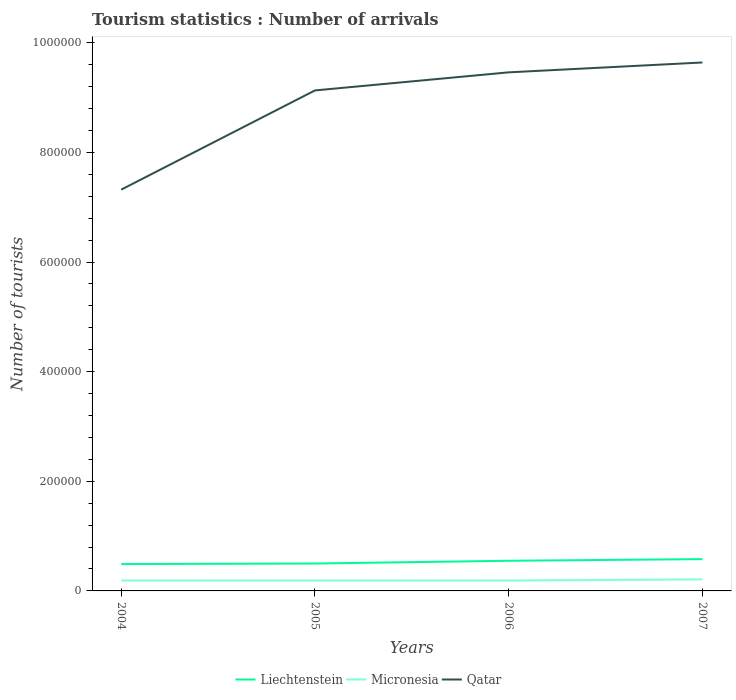Does the line corresponding to Liechtenstein intersect with the line corresponding to Micronesia?
Offer a terse response. No. Is the number of lines equal to the number of legend labels?
Provide a short and direct response. Yes. Across all years, what is the maximum number of tourist arrivals in Micronesia?
Make the answer very short. 1.90e+04. What is the total number of tourist arrivals in Micronesia in the graph?
Provide a succinct answer. 0. Are the values on the major ticks of Y-axis written in scientific E-notation?
Your answer should be very brief. No. Does the graph contain any zero values?
Your answer should be very brief. No. Where does the legend appear in the graph?
Make the answer very short. Bottom center. How are the legend labels stacked?
Offer a very short reply. Horizontal. What is the title of the graph?
Ensure brevity in your answer.  Tourism statistics : Number of arrivals. Does "Slovak Republic" appear as one of the legend labels in the graph?
Your answer should be compact. No. What is the label or title of the X-axis?
Offer a very short reply. Years. What is the label or title of the Y-axis?
Offer a terse response. Number of tourists. What is the Number of tourists in Liechtenstein in 2004?
Offer a terse response. 4.90e+04. What is the Number of tourists in Micronesia in 2004?
Your answer should be very brief. 1.90e+04. What is the Number of tourists in Qatar in 2004?
Keep it short and to the point. 7.32e+05. What is the Number of tourists of Micronesia in 2005?
Ensure brevity in your answer.  1.90e+04. What is the Number of tourists in Qatar in 2005?
Offer a terse response. 9.13e+05. What is the Number of tourists in Liechtenstein in 2006?
Make the answer very short. 5.50e+04. What is the Number of tourists in Micronesia in 2006?
Your response must be concise. 1.90e+04. What is the Number of tourists in Qatar in 2006?
Offer a terse response. 9.46e+05. What is the Number of tourists of Liechtenstein in 2007?
Your answer should be very brief. 5.80e+04. What is the Number of tourists in Micronesia in 2007?
Give a very brief answer. 2.10e+04. What is the Number of tourists of Qatar in 2007?
Ensure brevity in your answer.  9.64e+05. Across all years, what is the maximum Number of tourists in Liechtenstein?
Your answer should be very brief. 5.80e+04. Across all years, what is the maximum Number of tourists in Micronesia?
Make the answer very short. 2.10e+04. Across all years, what is the maximum Number of tourists in Qatar?
Give a very brief answer. 9.64e+05. Across all years, what is the minimum Number of tourists of Liechtenstein?
Provide a succinct answer. 4.90e+04. Across all years, what is the minimum Number of tourists of Micronesia?
Keep it short and to the point. 1.90e+04. Across all years, what is the minimum Number of tourists in Qatar?
Provide a succinct answer. 7.32e+05. What is the total Number of tourists of Liechtenstein in the graph?
Give a very brief answer. 2.12e+05. What is the total Number of tourists of Micronesia in the graph?
Your answer should be very brief. 7.80e+04. What is the total Number of tourists in Qatar in the graph?
Offer a very short reply. 3.56e+06. What is the difference between the Number of tourists in Liechtenstein in 2004 and that in 2005?
Provide a succinct answer. -1000. What is the difference between the Number of tourists of Micronesia in 2004 and that in 2005?
Offer a terse response. 0. What is the difference between the Number of tourists in Qatar in 2004 and that in 2005?
Your answer should be compact. -1.81e+05. What is the difference between the Number of tourists in Liechtenstein in 2004 and that in 2006?
Provide a succinct answer. -6000. What is the difference between the Number of tourists of Micronesia in 2004 and that in 2006?
Offer a very short reply. 0. What is the difference between the Number of tourists in Qatar in 2004 and that in 2006?
Provide a succinct answer. -2.14e+05. What is the difference between the Number of tourists of Liechtenstein in 2004 and that in 2007?
Give a very brief answer. -9000. What is the difference between the Number of tourists in Micronesia in 2004 and that in 2007?
Your answer should be very brief. -2000. What is the difference between the Number of tourists of Qatar in 2004 and that in 2007?
Make the answer very short. -2.32e+05. What is the difference between the Number of tourists of Liechtenstein in 2005 and that in 2006?
Your response must be concise. -5000. What is the difference between the Number of tourists in Micronesia in 2005 and that in 2006?
Provide a succinct answer. 0. What is the difference between the Number of tourists of Qatar in 2005 and that in 2006?
Your answer should be compact. -3.30e+04. What is the difference between the Number of tourists of Liechtenstein in 2005 and that in 2007?
Offer a very short reply. -8000. What is the difference between the Number of tourists in Micronesia in 2005 and that in 2007?
Offer a terse response. -2000. What is the difference between the Number of tourists of Qatar in 2005 and that in 2007?
Provide a succinct answer. -5.10e+04. What is the difference between the Number of tourists of Liechtenstein in 2006 and that in 2007?
Your response must be concise. -3000. What is the difference between the Number of tourists in Micronesia in 2006 and that in 2007?
Provide a succinct answer. -2000. What is the difference between the Number of tourists in Qatar in 2006 and that in 2007?
Your response must be concise. -1.80e+04. What is the difference between the Number of tourists of Liechtenstein in 2004 and the Number of tourists of Micronesia in 2005?
Keep it short and to the point. 3.00e+04. What is the difference between the Number of tourists of Liechtenstein in 2004 and the Number of tourists of Qatar in 2005?
Give a very brief answer. -8.64e+05. What is the difference between the Number of tourists in Micronesia in 2004 and the Number of tourists in Qatar in 2005?
Your answer should be compact. -8.94e+05. What is the difference between the Number of tourists of Liechtenstein in 2004 and the Number of tourists of Qatar in 2006?
Your answer should be compact. -8.97e+05. What is the difference between the Number of tourists in Micronesia in 2004 and the Number of tourists in Qatar in 2006?
Provide a short and direct response. -9.27e+05. What is the difference between the Number of tourists of Liechtenstein in 2004 and the Number of tourists of Micronesia in 2007?
Make the answer very short. 2.80e+04. What is the difference between the Number of tourists of Liechtenstein in 2004 and the Number of tourists of Qatar in 2007?
Make the answer very short. -9.15e+05. What is the difference between the Number of tourists of Micronesia in 2004 and the Number of tourists of Qatar in 2007?
Keep it short and to the point. -9.45e+05. What is the difference between the Number of tourists of Liechtenstein in 2005 and the Number of tourists of Micronesia in 2006?
Your answer should be very brief. 3.10e+04. What is the difference between the Number of tourists in Liechtenstein in 2005 and the Number of tourists in Qatar in 2006?
Keep it short and to the point. -8.96e+05. What is the difference between the Number of tourists in Micronesia in 2005 and the Number of tourists in Qatar in 2006?
Provide a succinct answer. -9.27e+05. What is the difference between the Number of tourists in Liechtenstein in 2005 and the Number of tourists in Micronesia in 2007?
Offer a very short reply. 2.90e+04. What is the difference between the Number of tourists in Liechtenstein in 2005 and the Number of tourists in Qatar in 2007?
Provide a succinct answer. -9.14e+05. What is the difference between the Number of tourists in Micronesia in 2005 and the Number of tourists in Qatar in 2007?
Provide a succinct answer. -9.45e+05. What is the difference between the Number of tourists in Liechtenstein in 2006 and the Number of tourists in Micronesia in 2007?
Offer a very short reply. 3.40e+04. What is the difference between the Number of tourists of Liechtenstein in 2006 and the Number of tourists of Qatar in 2007?
Your answer should be very brief. -9.09e+05. What is the difference between the Number of tourists of Micronesia in 2006 and the Number of tourists of Qatar in 2007?
Your answer should be compact. -9.45e+05. What is the average Number of tourists in Liechtenstein per year?
Keep it short and to the point. 5.30e+04. What is the average Number of tourists of Micronesia per year?
Offer a terse response. 1.95e+04. What is the average Number of tourists in Qatar per year?
Keep it short and to the point. 8.89e+05. In the year 2004, what is the difference between the Number of tourists in Liechtenstein and Number of tourists in Qatar?
Ensure brevity in your answer.  -6.83e+05. In the year 2004, what is the difference between the Number of tourists of Micronesia and Number of tourists of Qatar?
Provide a succinct answer. -7.13e+05. In the year 2005, what is the difference between the Number of tourists of Liechtenstein and Number of tourists of Micronesia?
Your answer should be very brief. 3.10e+04. In the year 2005, what is the difference between the Number of tourists of Liechtenstein and Number of tourists of Qatar?
Offer a terse response. -8.63e+05. In the year 2005, what is the difference between the Number of tourists of Micronesia and Number of tourists of Qatar?
Keep it short and to the point. -8.94e+05. In the year 2006, what is the difference between the Number of tourists of Liechtenstein and Number of tourists of Micronesia?
Make the answer very short. 3.60e+04. In the year 2006, what is the difference between the Number of tourists in Liechtenstein and Number of tourists in Qatar?
Provide a succinct answer. -8.91e+05. In the year 2006, what is the difference between the Number of tourists of Micronesia and Number of tourists of Qatar?
Ensure brevity in your answer.  -9.27e+05. In the year 2007, what is the difference between the Number of tourists of Liechtenstein and Number of tourists of Micronesia?
Provide a succinct answer. 3.70e+04. In the year 2007, what is the difference between the Number of tourists of Liechtenstein and Number of tourists of Qatar?
Keep it short and to the point. -9.06e+05. In the year 2007, what is the difference between the Number of tourists in Micronesia and Number of tourists in Qatar?
Offer a very short reply. -9.43e+05. What is the ratio of the Number of tourists in Qatar in 2004 to that in 2005?
Make the answer very short. 0.8. What is the ratio of the Number of tourists of Liechtenstein in 2004 to that in 2006?
Make the answer very short. 0.89. What is the ratio of the Number of tourists in Qatar in 2004 to that in 2006?
Make the answer very short. 0.77. What is the ratio of the Number of tourists of Liechtenstein in 2004 to that in 2007?
Offer a terse response. 0.84. What is the ratio of the Number of tourists of Micronesia in 2004 to that in 2007?
Provide a succinct answer. 0.9. What is the ratio of the Number of tourists of Qatar in 2004 to that in 2007?
Keep it short and to the point. 0.76. What is the ratio of the Number of tourists in Qatar in 2005 to that in 2006?
Make the answer very short. 0.97. What is the ratio of the Number of tourists in Liechtenstein in 2005 to that in 2007?
Make the answer very short. 0.86. What is the ratio of the Number of tourists in Micronesia in 2005 to that in 2007?
Keep it short and to the point. 0.9. What is the ratio of the Number of tourists of Qatar in 2005 to that in 2007?
Keep it short and to the point. 0.95. What is the ratio of the Number of tourists of Liechtenstein in 2006 to that in 2007?
Provide a succinct answer. 0.95. What is the ratio of the Number of tourists of Micronesia in 2006 to that in 2007?
Keep it short and to the point. 0.9. What is the ratio of the Number of tourists of Qatar in 2006 to that in 2007?
Keep it short and to the point. 0.98. What is the difference between the highest and the second highest Number of tourists of Liechtenstein?
Keep it short and to the point. 3000. What is the difference between the highest and the second highest Number of tourists of Qatar?
Make the answer very short. 1.80e+04. What is the difference between the highest and the lowest Number of tourists of Liechtenstein?
Provide a short and direct response. 9000. What is the difference between the highest and the lowest Number of tourists of Qatar?
Ensure brevity in your answer.  2.32e+05. 